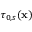Convert formula to latex. <formula><loc_0><loc_0><loc_500><loc_500>\tau _ { 0 , s } ( x )</formula> 